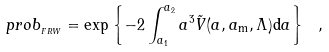Convert formula to latex. <formula><loc_0><loc_0><loc_500><loc_500>p r o b _ { _ { F R W } } = \exp \left \{ - 2 \int ^ { a _ { 2 } } _ { a _ { 1 } } a ^ { 3 } \tilde { V } ( a , a _ { \mathrm m } , \Lambda ) \mathrm d a \right \} \ ,</formula> 